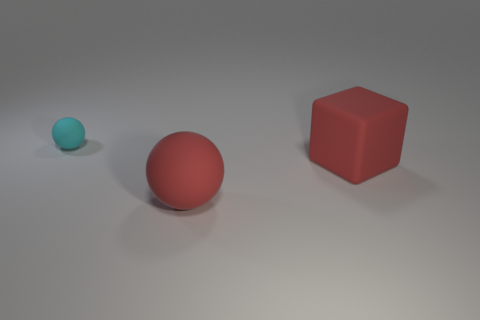Is there anything else that has the same size as the cyan rubber thing?
Your answer should be compact. No. There is a rubber ball that is behind the red matte block; what is its size?
Ensure brevity in your answer.  Small. There is a red sphere that is made of the same material as the large red block; what size is it?
Give a very brief answer. Large. How many big cubes are the same color as the small ball?
Offer a terse response. 0. Are there any purple spheres?
Ensure brevity in your answer.  No. Do the small cyan object and the big thing to the right of the large ball have the same shape?
Provide a succinct answer. No. What color is the ball behind the red matte object behind the red thing that is in front of the matte block?
Give a very brief answer. Cyan. Are there any matte balls behind the block?
Your answer should be very brief. Yes. There is a object that is the same color as the cube; what is its size?
Offer a very short reply. Large. Are there any large red spheres that have the same material as the small cyan object?
Ensure brevity in your answer.  Yes. 